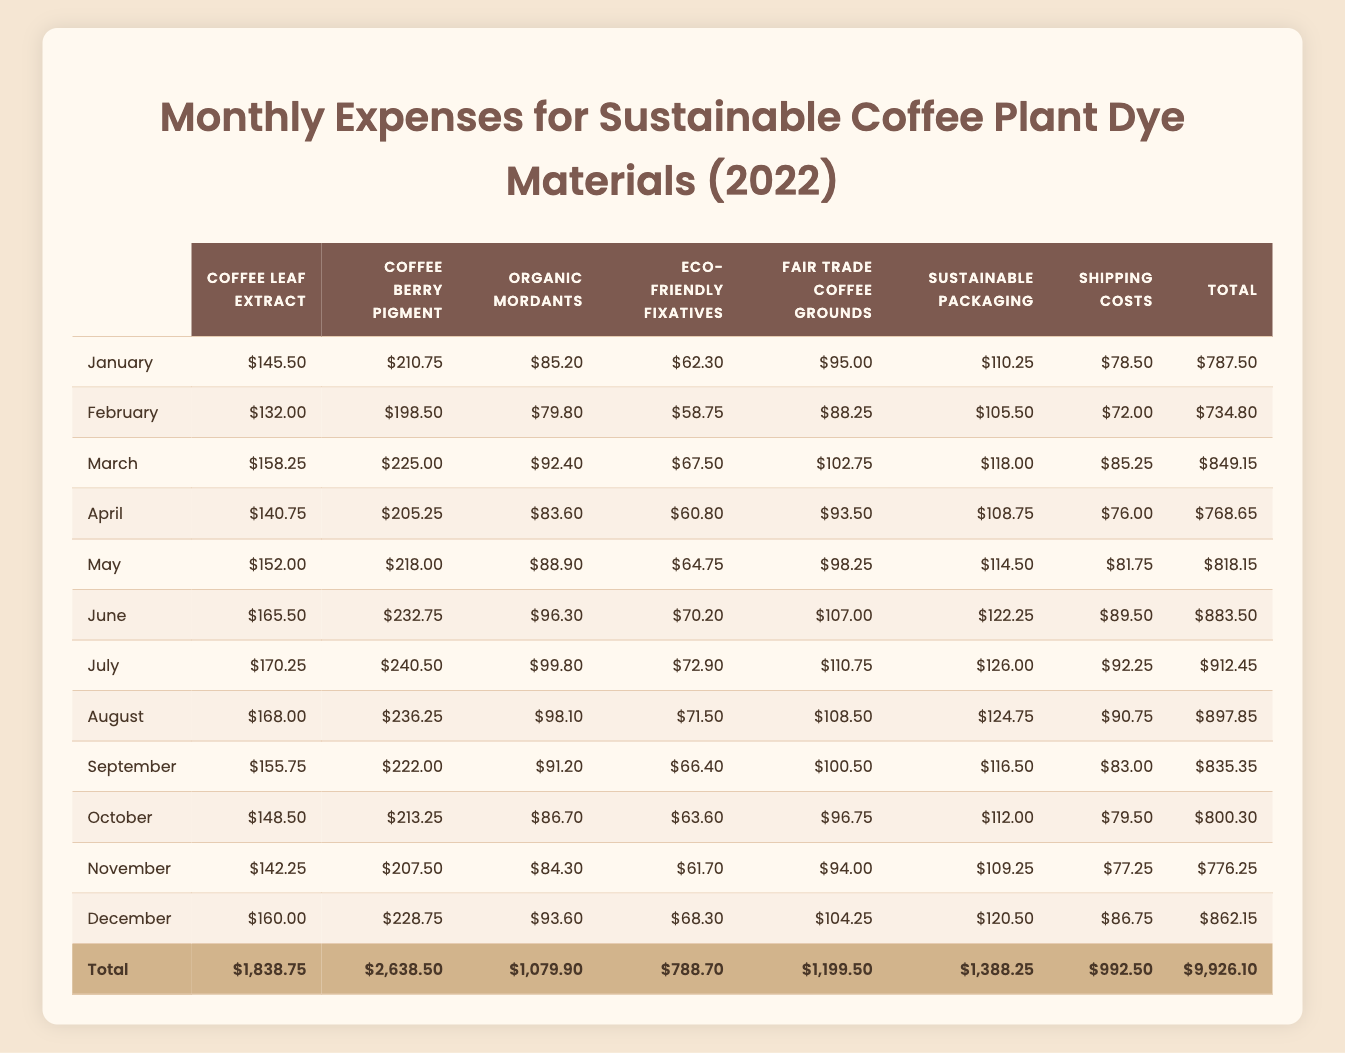What is the total expense for coffee leaf extract in December? The total expense for coffee leaf extract in December is listed in the table, which shows $160.00 for that month.
Answer: $160.00 What were the shipping costs for June? The shipping costs for June can be found in the table, which indicates they were $89.50.
Answer: $89.50 Which month had the highest overall expenses? By looking at the total expenses column in the table, July had the highest overall expenses at $912.45.
Answer: July What is the average amount spent on eco-friendly fixatives over the year? To calculate the average, sum the monthly expenses for eco-friendly fixatives: (62.30 + 58.75 + 67.50 + 60.80 + 64.75 + 70.20 + 72.90 + 71.50 + 66.40 + 63.60 + 61.70 + 68.30) = 788.70. There are 12 months, so divide the total by 12: 788.70 / 12 = 65.725. Rounded, the average is approximately $65.73.
Answer: $65.73 Did the total expenses for sustainable packaging exceed $1,300 for the entire year? To find out if the total for sustainable packaging exceeded $1,300, add up all the monthly expenses: (110.25 + 105.50 + 118.00 + 108.75 + 114.50 + 122.25 + 126.00 + 124.75 + 116.50 + 112.00 + 109.25 + 120.50) = 1,388.25, which is greater than $1,300.
Answer: Yes Which month had a higher expense for coffee berry pigment: March or July? Looking at the table, March shows $225.00 while July shows $240.50. Since $240.50 > $225.00, July had a higher expense.
Answer: July What was the difference in expenses for organic mordants between February and November? The expenses for organic mordants in February and November are $79.80 and $84.30, respectively. To find the difference, calculate: 84.30 - 79.80 = 4.50.
Answer: $4.50 What was the total expense across all categories for May? To find the total for May, add the individual expenses: (152.00 + 218.00 + 88.90 + 64.75 + 98.25 + 114.50 + 81.75) = 818.15, confirming May's total expense.
Answer: $818.15 